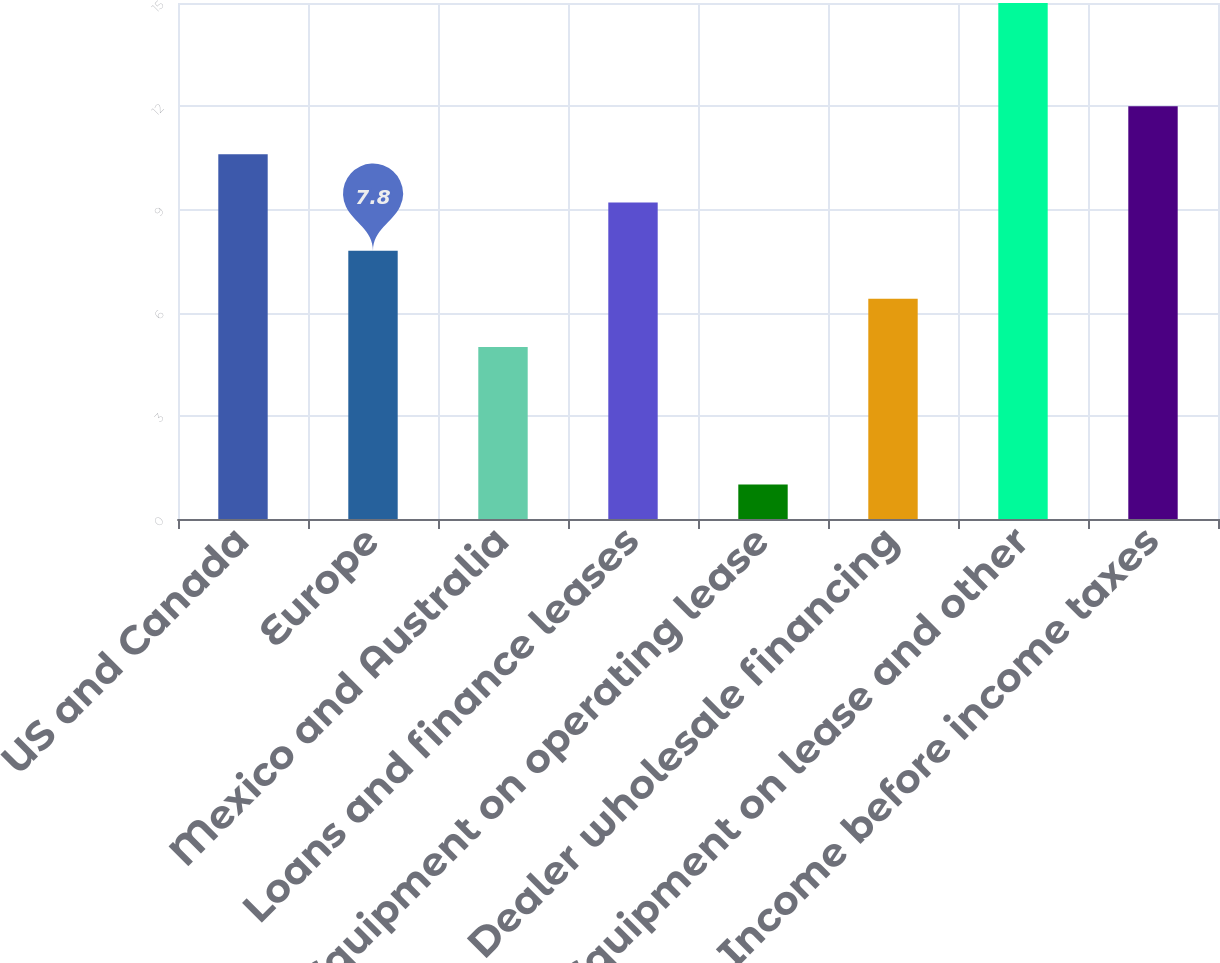<chart> <loc_0><loc_0><loc_500><loc_500><bar_chart><fcel>US and Canada<fcel>Europe<fcel>Mexico and Australia<fcel>Loans and finance leases<fcel>Equipment on operating lease<fcel>Dealer wholesale financing<fcel>Equipment on lease and other<fcel>Income before income taxes<nl><fcel>10.6<fcel>7.8<fcel>5<fcel>9.2<fcel>1<fcel>6.4<fcel>15<fcel>12<nl></chart> 